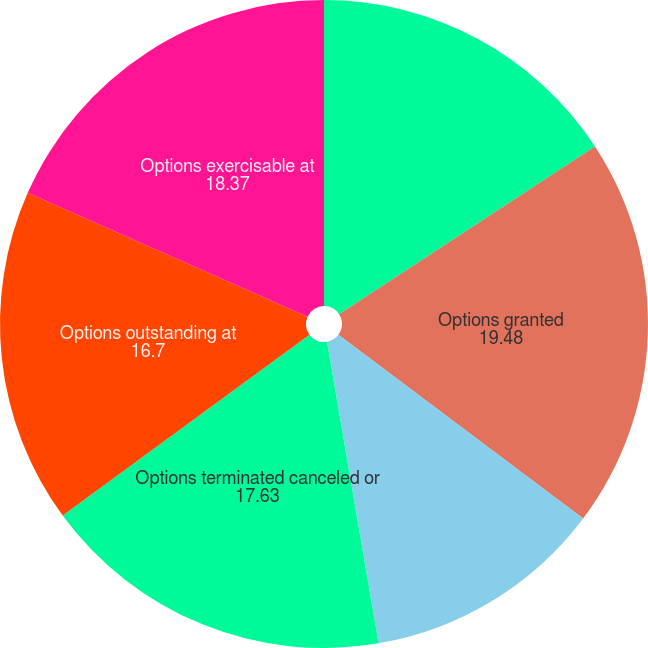Convert chart. <chart><loc_0><loc_0><loc_500><loc_500><pie_chart><fcel>Options outstanding at January<fcel>Options granted<fcel>Options exercised<fcel>Options terminated canceled or<fcel>Options outstanding at<fcel>Options exercisable at<nl><fcel>15.77%<fcel>19.48%<fcel>12.06%<fcel>17.63%<fcel>16.7%<fcel>18.37%<nl></chart> 